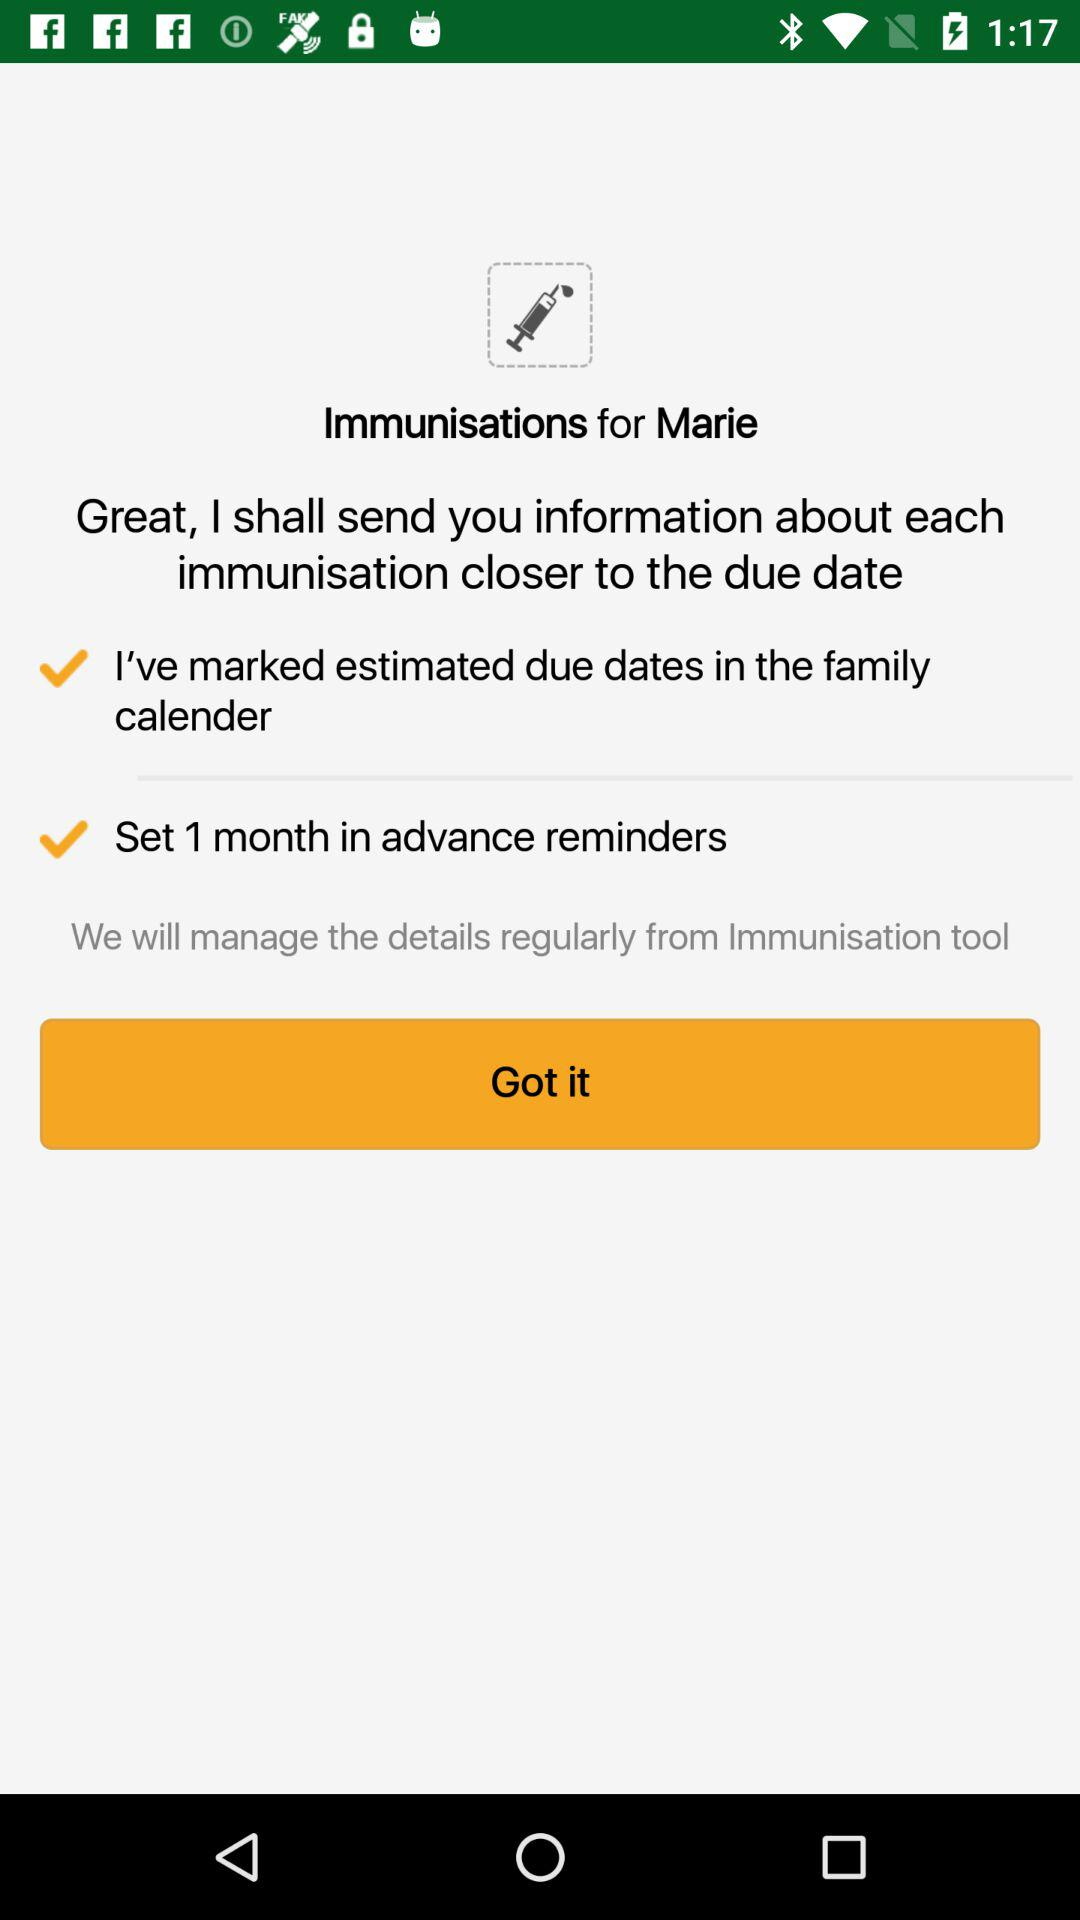How many reminders are set for Marie's immunizations?
Answer the question using a single word or phrase. 1 